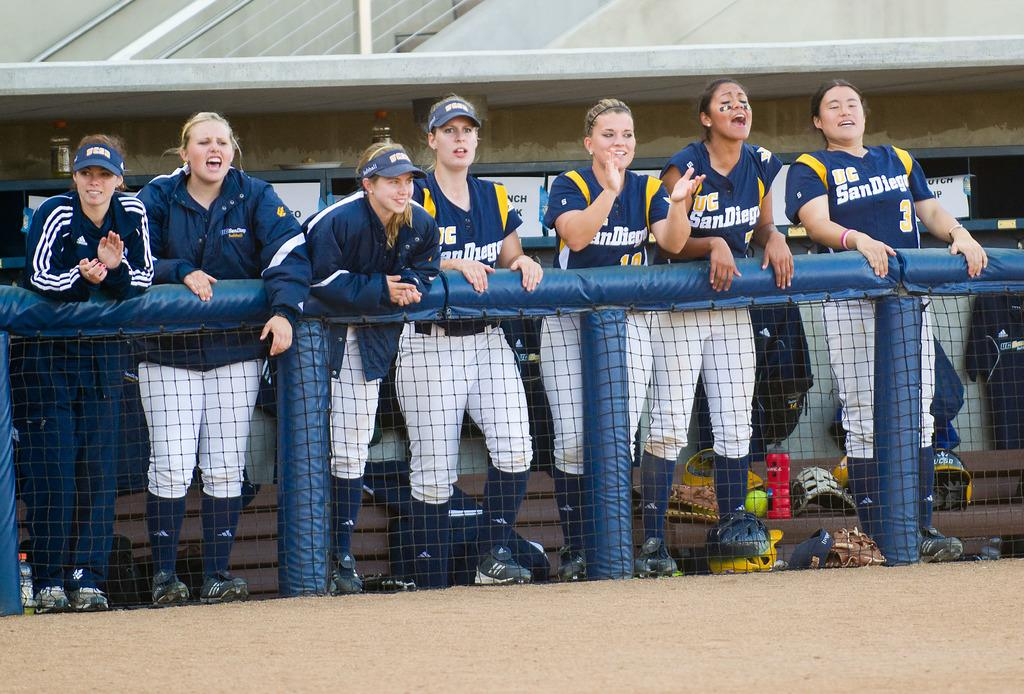<image>
Share a concise interpretation of the image provided. Several UC San Diego players cheer from the dugout. 